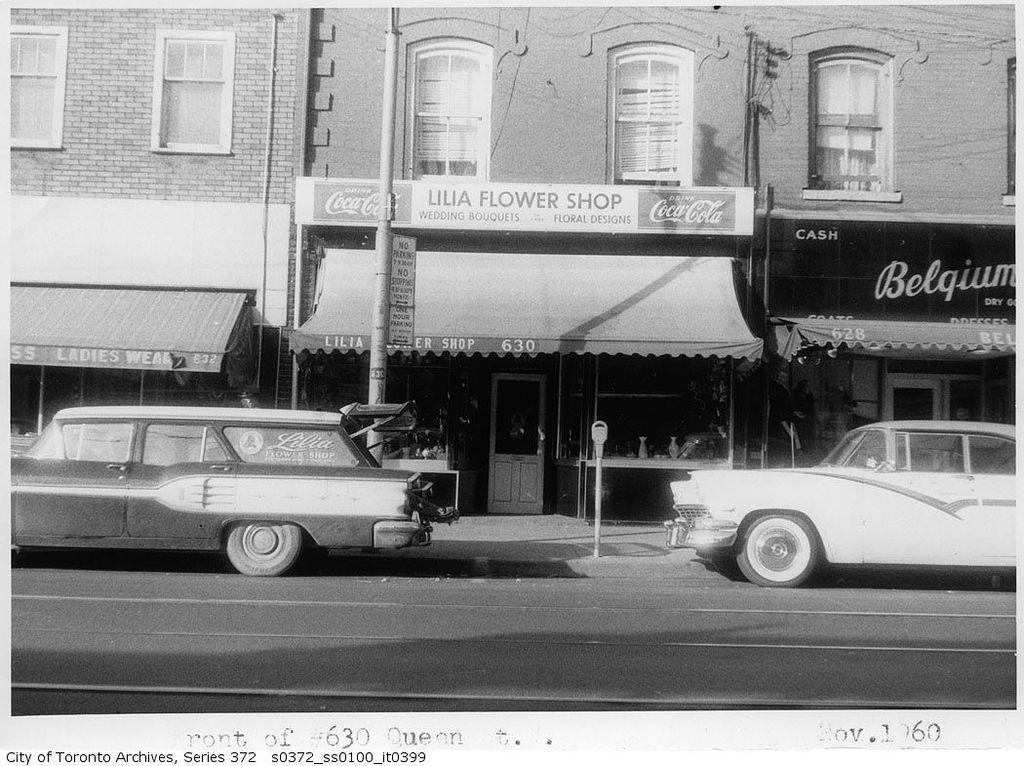In one or two sentences, can you explain what this image depicts? In this picture I can see the cars on the road. In the back I can see the building. On the right I can see the advertisement board. In the center I can see the banners on this electric pole. At the bottom I can see the watermark. At the top I can see some windows. 